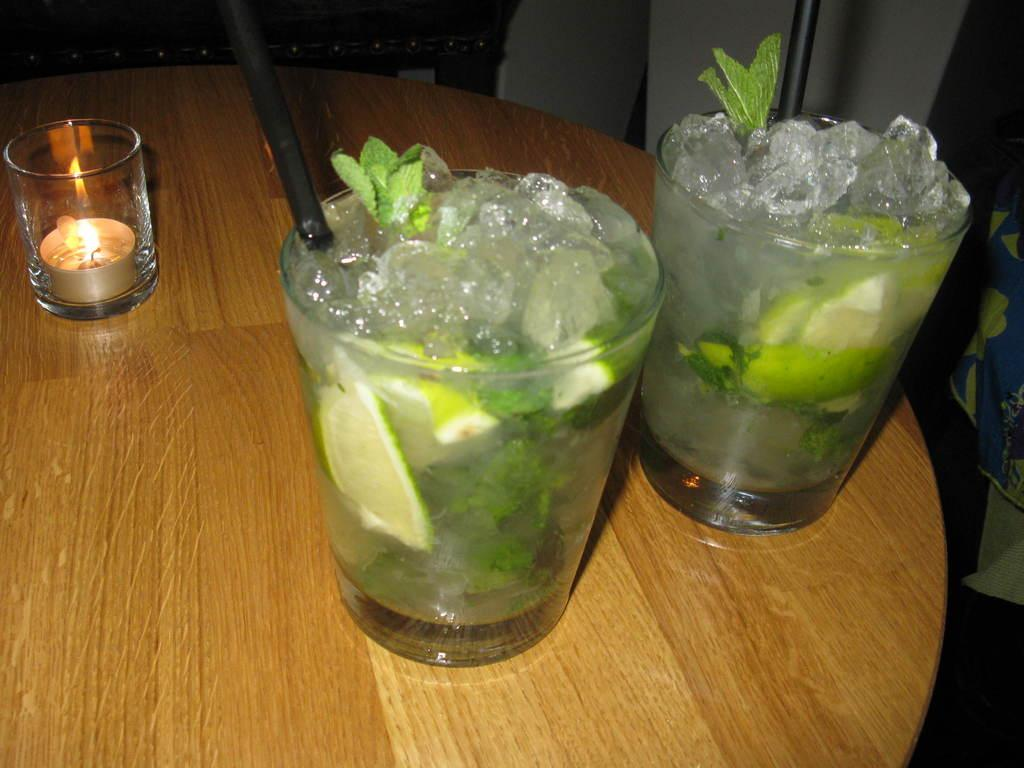What type of objects can be seen in the image? There are glasses, straws, a candle, ice cubes, leaves, and lemon slices in the image. What might be used to stir or mix the contents of the glasses? The straws in the image could be used to stir or mix the contents of the glasses. What is the surface on which the objects are placed? The objects are on a wooden table. What is the purpose of the candle in the image? The purpose of the candle in the image is not clear, but it could be for decoration or to provide light. What type of crook is present in the image? There is no crook present in the image. What list can be seen on the wooden table? There is no list visible in the image. 